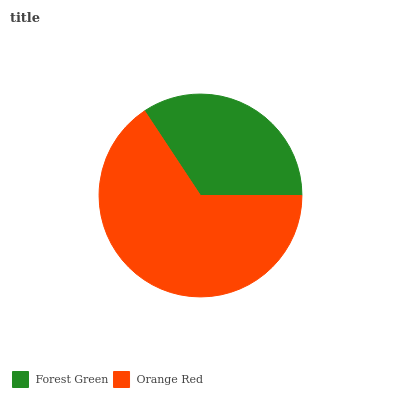Is Forest Green the minimum?
Answer yes or no. Yes. Is Orange Red the maximum?
Answer yes or no. Yes. Is Orange Red the minimum?
Answer yes or no. No. Is Orange Red greater than Forest Green?
Answer yes or no. Yes. Is Forest Green less than Orange Red?
Answer yes or no. Yes. Is Forest Green greater than Orange Red?
Answer yes or no. No. Is Orange Red less than Forest Green?
Answer yes or no. No. Is Orange Red the high median?
Answer yes or no. Yes. Is Forest Green the low median?
Answer yes or no. Yes. Is Forest Green the high median?
Answer yes or no. No. Is Orange Red the low median?
Answer yes or no. No. 